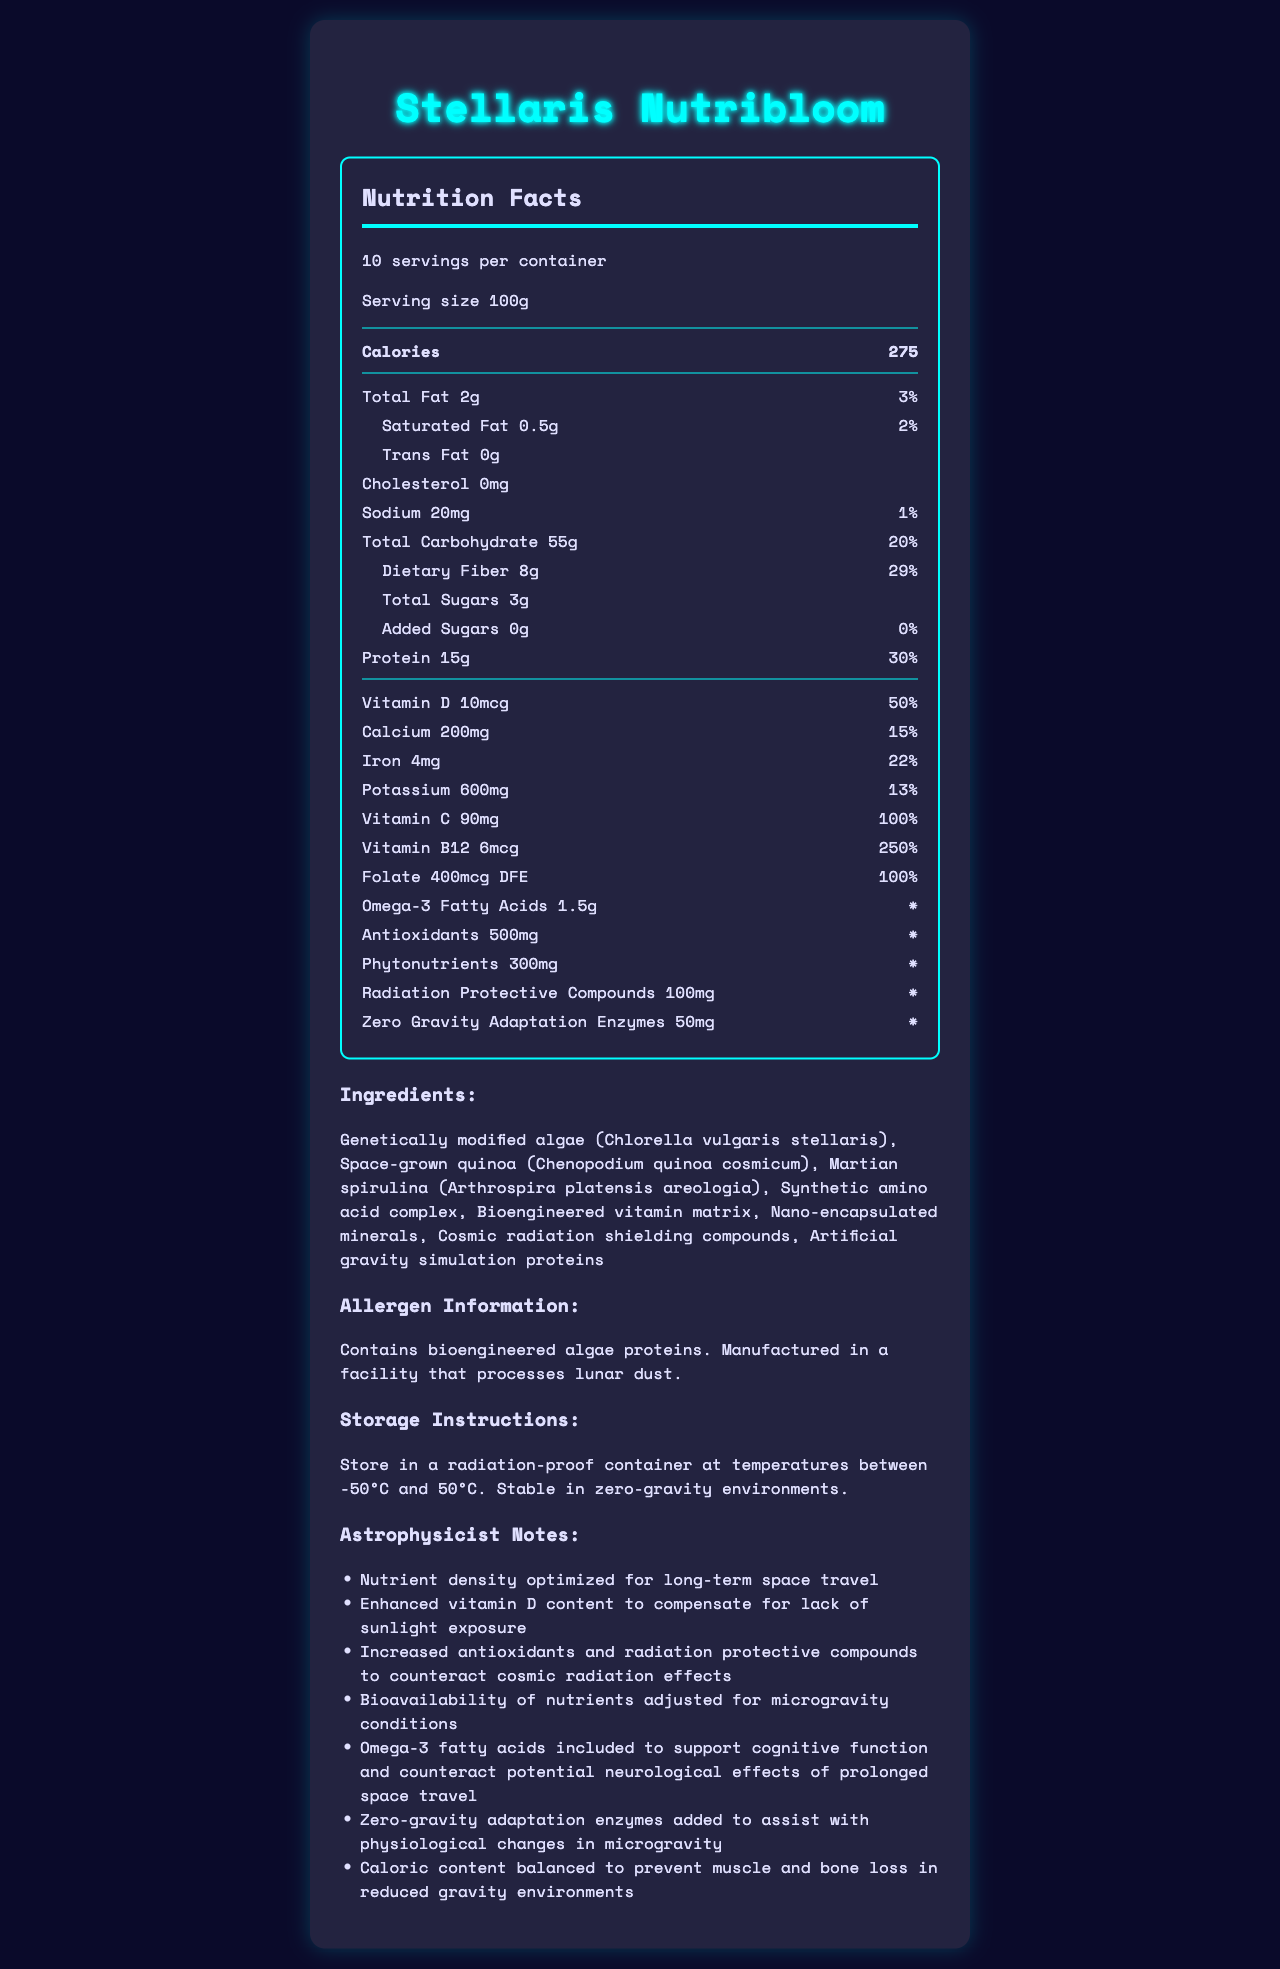what is the serving size? The serving size is stated at the top of the nutrition facts label: "Serving size 100g."
Answer: 100g how many calories are in one serving? The calories per serving are listed as 275.
Answer: 275 what is the daily value percentage for dietary fiber? Under the nutrient section, dietary fiber is listed with a daily value of 29%.
Answer: 29% What is the primary ingredient in Stellaris Nutribloom? The primary ingredient, which is listed first, is genetically modified algae (Chlorella vulgaris stellaris).
Answer: Genetically modified algae (Chlorella vulgaris stellaris) what is the amount of added sugars per serving? The document lists added sugars as 0g.
Answer: 0g Which of these vitamins has the highest daily value percentage in Stellaris Nutribloom? A. Vitamin D B. Vitamin C C. Vitamin B12 D. Folate Vitamin B12 has a daily value percentage of 250%, which is the highest among the listed vitamins.
Answer: C. Vitamin B12 Which of these compounds is specifically included for radiation protection? I. Omega-3 Fatty Acids II. Phytonutrients III. Radiation Protective Compounds IV. Zero Gravity Adaptation Enzymes Radiation Protective Compounds are mentioned explicitly for radiation protection in both the nutrient label and the astrophysicist notes.
Answer: III. Radiation Protective Compounds Is there any cholesterol in Stellaris Nutribloom? The nutrition label specifies that the cholesterol content is 0mg.
Answer: No summarize the main purpose of Stellaris Nutribloom as stated in the document. The entire document focuses on describing Stellaris Nutribloom's nutrient profile, ingredients, storage instructions, and special enhancements for long-term space missions, emphasizing how it supports astronaut health in space environments.
Answer: Stellaris Nutribloom is a genetically modified space crop designed for long-term interstellar missions, optimized for nutrient density to support astronauts in space. It includes enhanced nutrients to compensate for the lack of sunlight, antioxidants, and radiation protective compounds for cosmic radiation, and is adapted for microgravity conditions. Does the Stellaris Nutribloom contain any allergens? The allergen information states that it "Contains bioengineered algae proteins."
Answer: Yes What is the total acceptable temperature range for storing Stellaris Nutribloom? The storage instructions specify that it should be stored at temperatures between -50°C and 50°C.
Answer: -50°C to 50°C can Stellaris Nutribloom be stored in zero-gravity environments? The storage instructions explicitly state that it is "Stable in zero-gravity environments."
Answer: Yes what specific type of quinoa is used in Stellaris Nutribloom? The ingredients list includes "Space-grown quinoa (Chenopodium quinoa cosmicum)."
Answer: Space-grown quinoa (Chenopodium quinoa cosmicum) Who developed Stellaris Nutribloom? The document does not provide information about who developed Stellaris Nutribloom.
Answer: Cannot be determined 